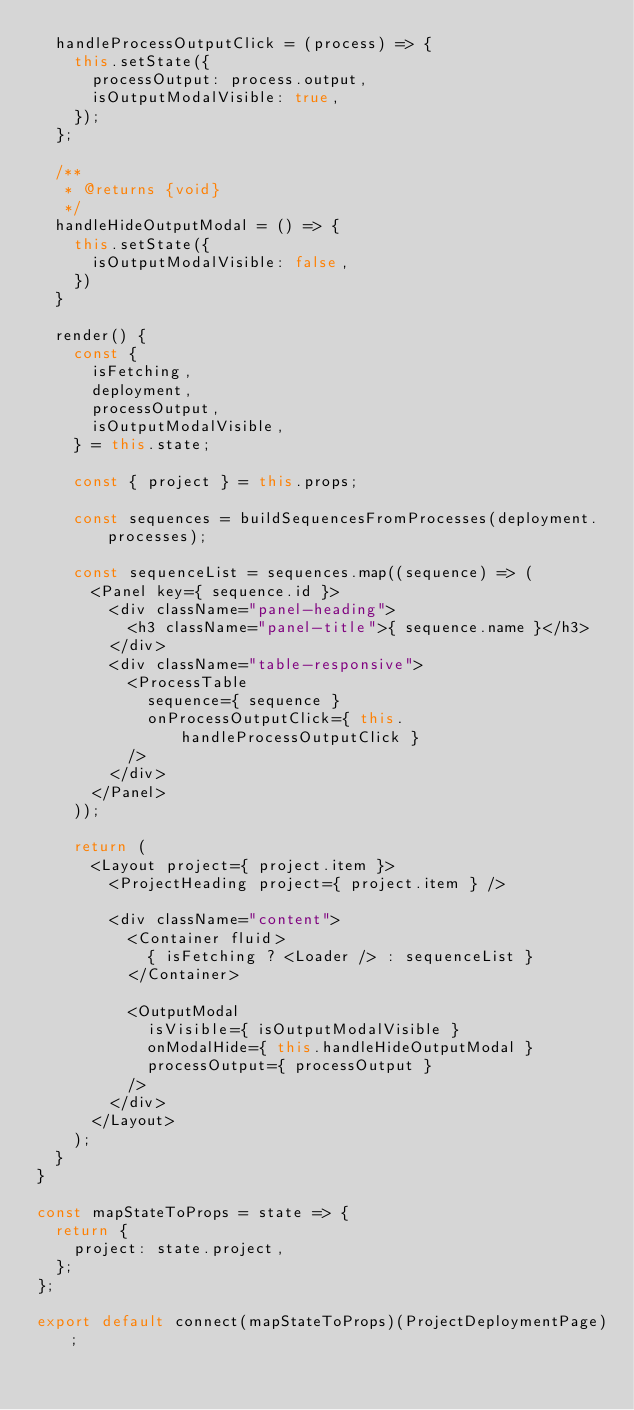Convert code to text. <code><loc_0><loc_0><loc_500><loc_500><_JavaScript_>  handleProcessOutputClick = (process) => {
    this.setState({
      processOutput: process.output,
      isOutputModalVisible: true,
    });
  };

  /**
   * @returns {void}
   */
  handleHideOutputModal = () => {
    this.setState({
      isOutputModalVisible: false,
    })
  }

  render() {
    const { 
      isFetching,
      deployment,
      processOutput,
      isOutputModalVisible,
    } = this.state;
  
    const { project } = this.props;

    const sequences = buildSequencesFromProcesses(deployment.processes);

    const sequenceList = sequences.map((sequence) => (
      <Panel key={ sequence.id }>
        <div className="panel-heading">
          <h3 className="panel-title">{ sequence.name }</h3>
        </div>
        <div className="table-responsive">
          <ProcessTable
            sequence={ sequence }
            onProcessOutputClick={ this.handleProcessOutputClick }
          />
        </div>
      </Panel>
    ));

    return (
      <Layout project={ project.item }>
        <ProjectHeading project={ project.item } />

        <div className="content">
          <Container fluid>
            { isFetching ? <Loader /> : sequenceList }
          </Container>

          <OutputModal
            isVisible={ isOutputModalVisible }
            onModalHide={ this.handleHideOutputModal }
            processOutput={ processOutput }
          />
        </div>
      </Layout>
    );
  }
}

const mapStateToProps = state => {
  return {
    project: state.project,
  };
};

export default connect(mapStateToProps)(ProjectDeploymentPage);
</code> 